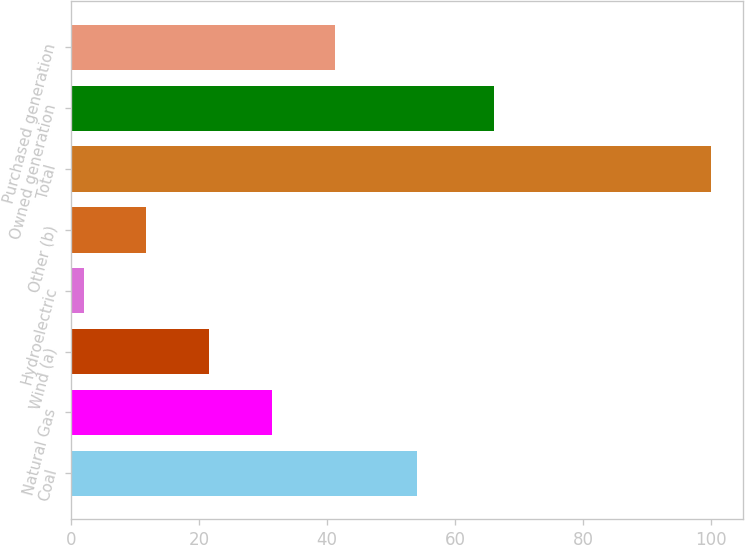<chart> <loc_0><loc_0><loc_500><loc_500><bar_chart><fcel>Coal<fcel>Natural Gas<fcel>Wind (a)<fcel>Hydroelectric<fcel>Other (b)<fcel>Total<fcel>Owned generation<fcel>Purchased generation<nl><fcel>54<fcel>31.4<fcel>21.6<fcel>2<fcel>11.8<fcel>100<fcel>66<fcel>41.2<nl></chart> 